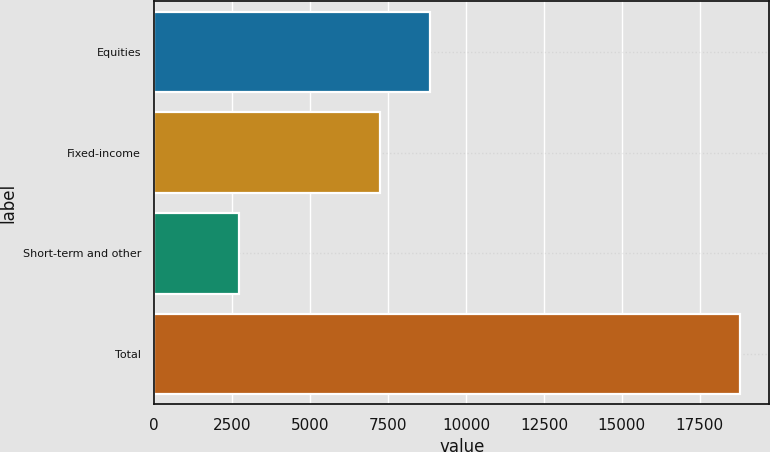Convert chart. <chart><loc_0><loc_0><loc_500><loc_500><bar_chart><fcel>Equities<fcel>Fixed-income<fcel>Short-term and other<fcel>Total<nl><fcel>8842.4<fcel>7236<fcel>2731<fcel>18795<nl></chart> 